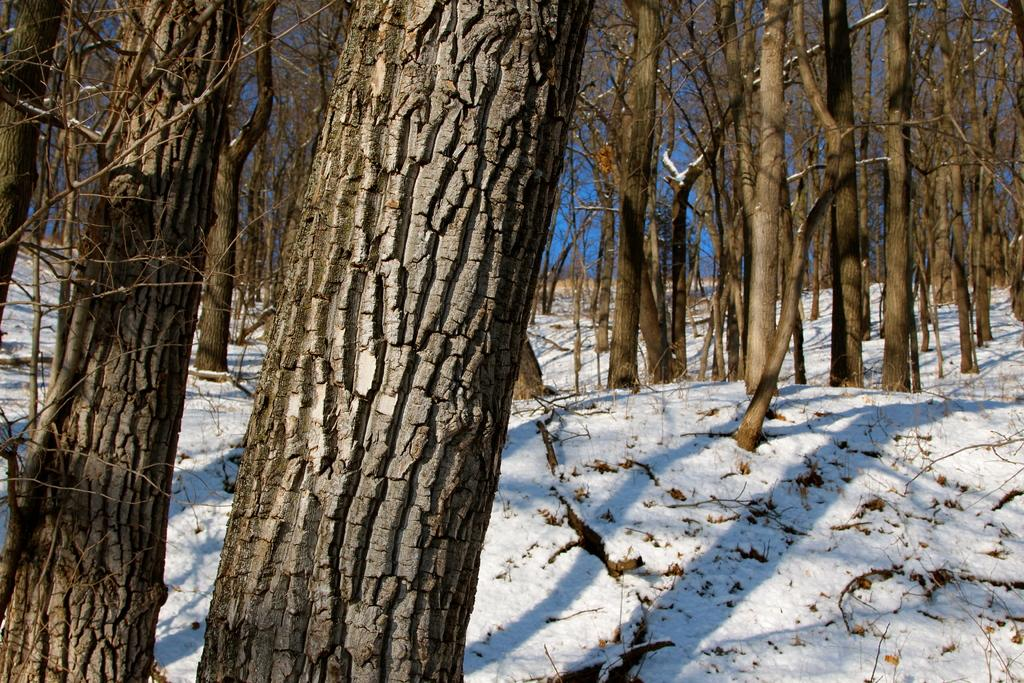What type of natural objects can be seen in the image? There are tree trunks in the image. What is covering the ground in the image? Snow is present on the ground in the image. What part of the environment is visible in the image? The sky is visible in the image. What type of letters can be seen on the tree trunks in the image? There are no letters present on the tree trunks in the image. What kind of beast is hiding behind the tree trunks in the image? There is no beast present in the image; it only features tree trunks and snow-covered ground. 